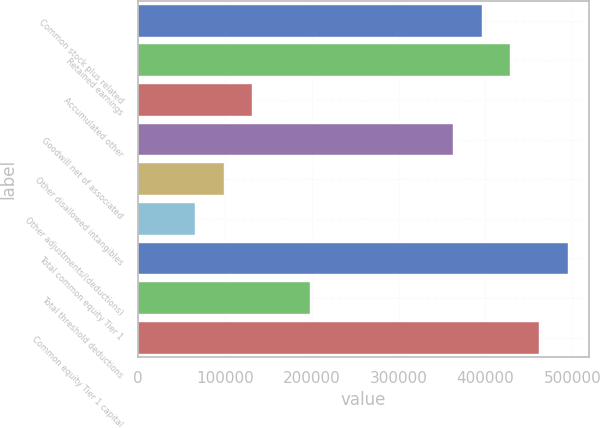Convert chart to OTSL. <chart><loc_0><loc_0><loc_500><loc_500><bar_chart><fcel>Common stock plus related<fcel>Retained earnings<fcel>Accumulated other<fcel>Goodwill net of associated<fcel>Other disallowed intangibles<fcel>Other adjustments/(deductions)<fcel>Total common equity Tier 1<fcel>Total threshold deductions<fcel>Common equity Tier 1 capital<nl><fcel>395792<fcel>428774<fcel>131932<fcel>362810<fcel>98949.5<fcel>65967<fcel>494740<fcel>197897<fcel>461757<nl></chart> 